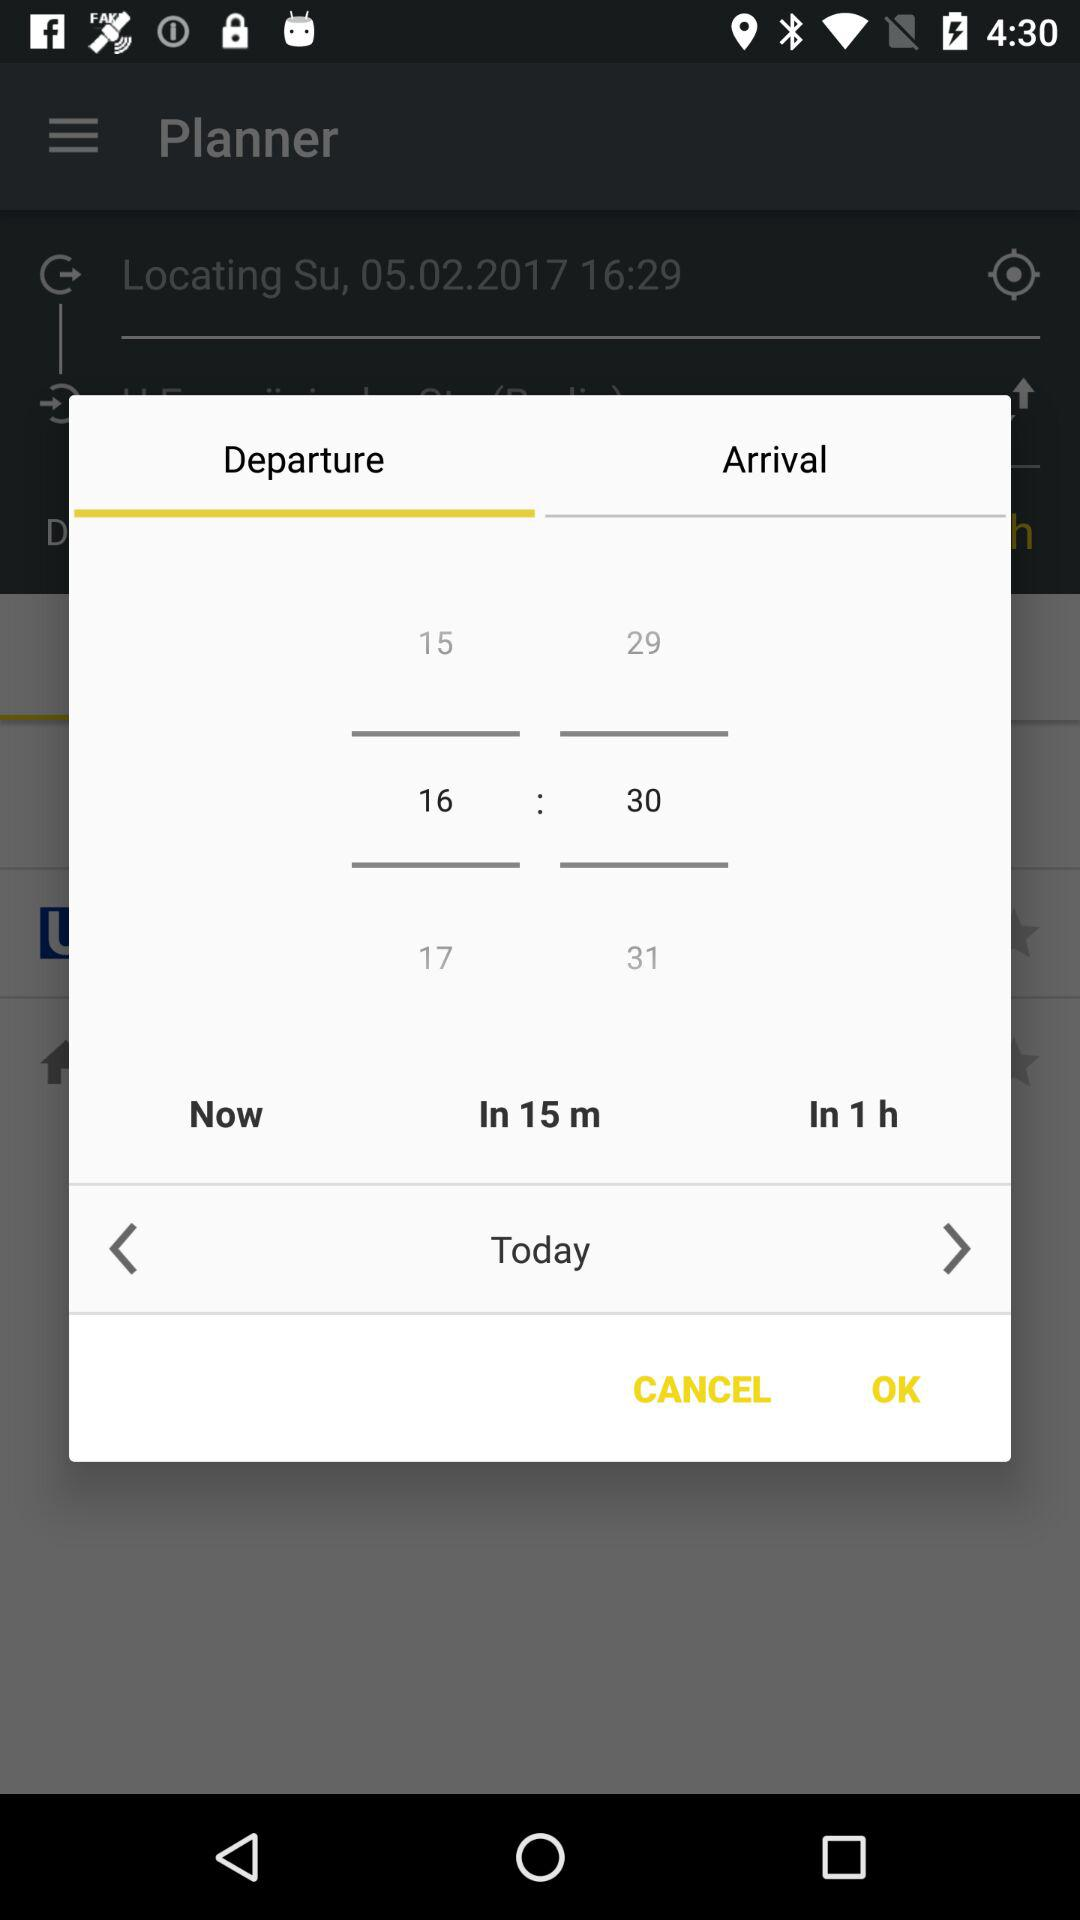What time is selected? The selected time is 16:30. 